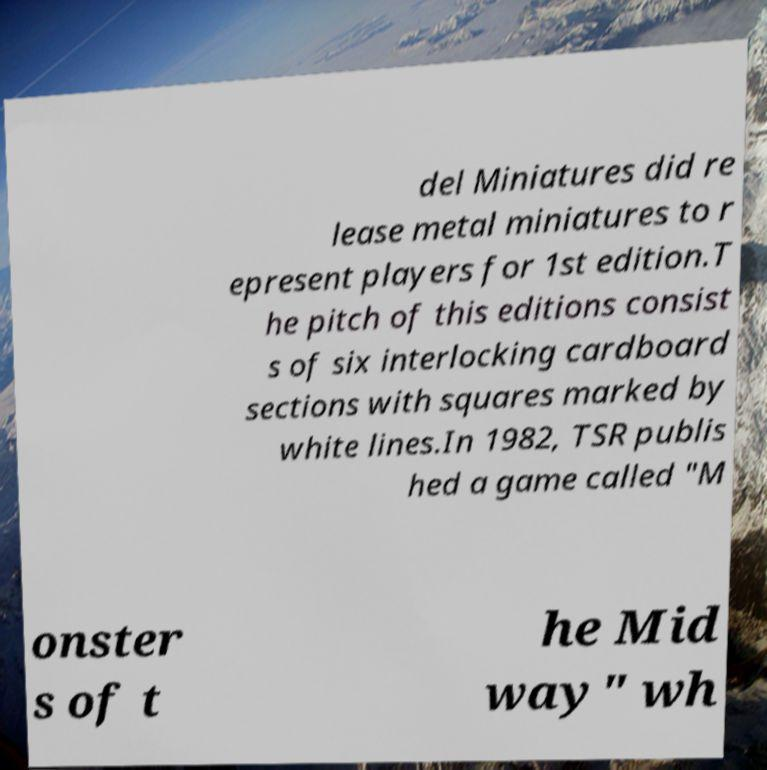Please read and relay the text visible in this image. What does it say? del Miniatures did re lease metal miniatures to r epresent players for 1st edition.T he pitch of this editions consist s of six interlocking cardboard sections with squares marked by white lines.In 1982, TSR publis hed a game called "M onster s of t he Mid way" wh 